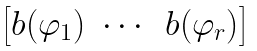Convert formula to latex. <formula><loc_0><loc_0><loc_500><loc_500>\begin{bmatrix} b ( \varphi _ { 1 } ) & \cdots & b ( \varphi _ { r } ) \end{bmatrix}</formula> 